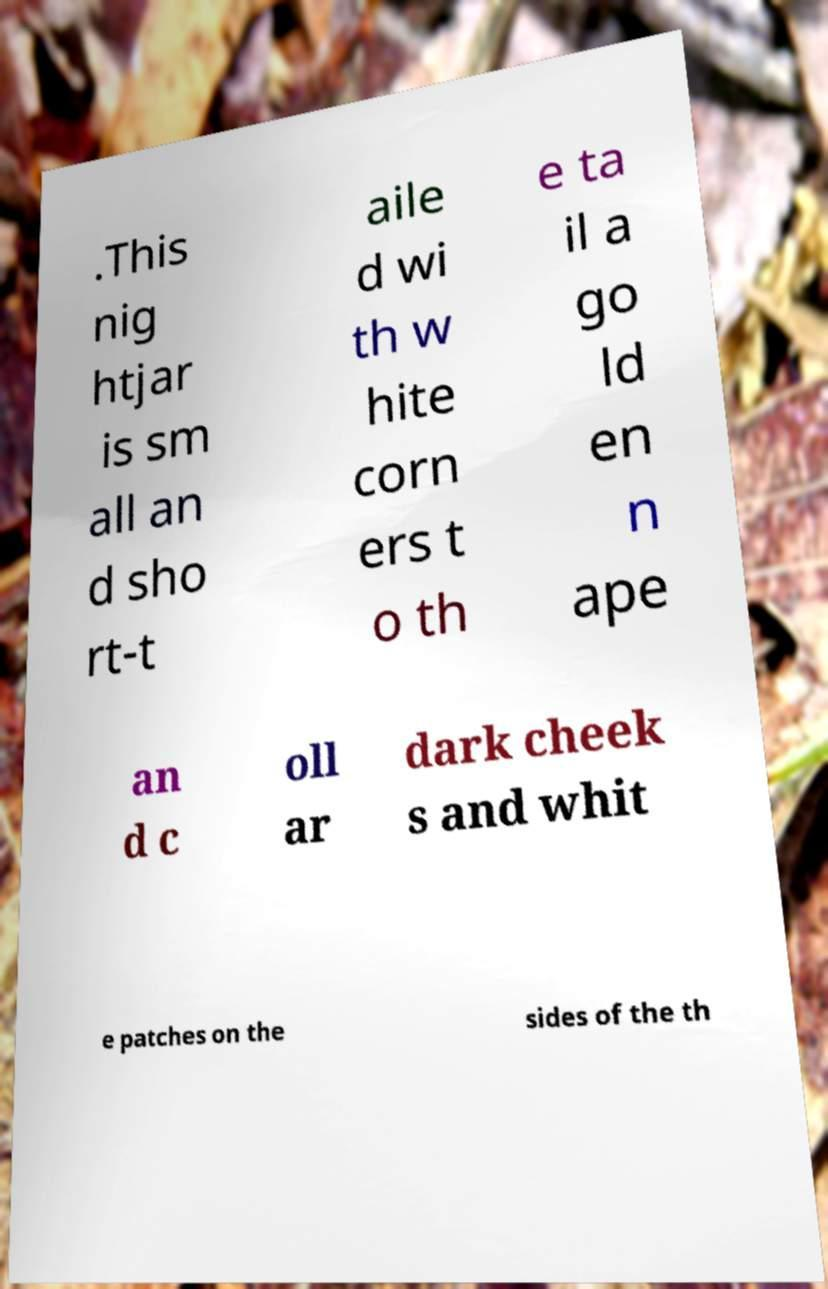There's text embedded in this image that I need extracted. Can you transcribe it verbatim? .This nig htjar is sm all an d sho rt-t aile d wi th w hite corn ers t o th e ta il a go ld en n ape an d c oll ar dark cheek s and whit e patches on the sides of the th 